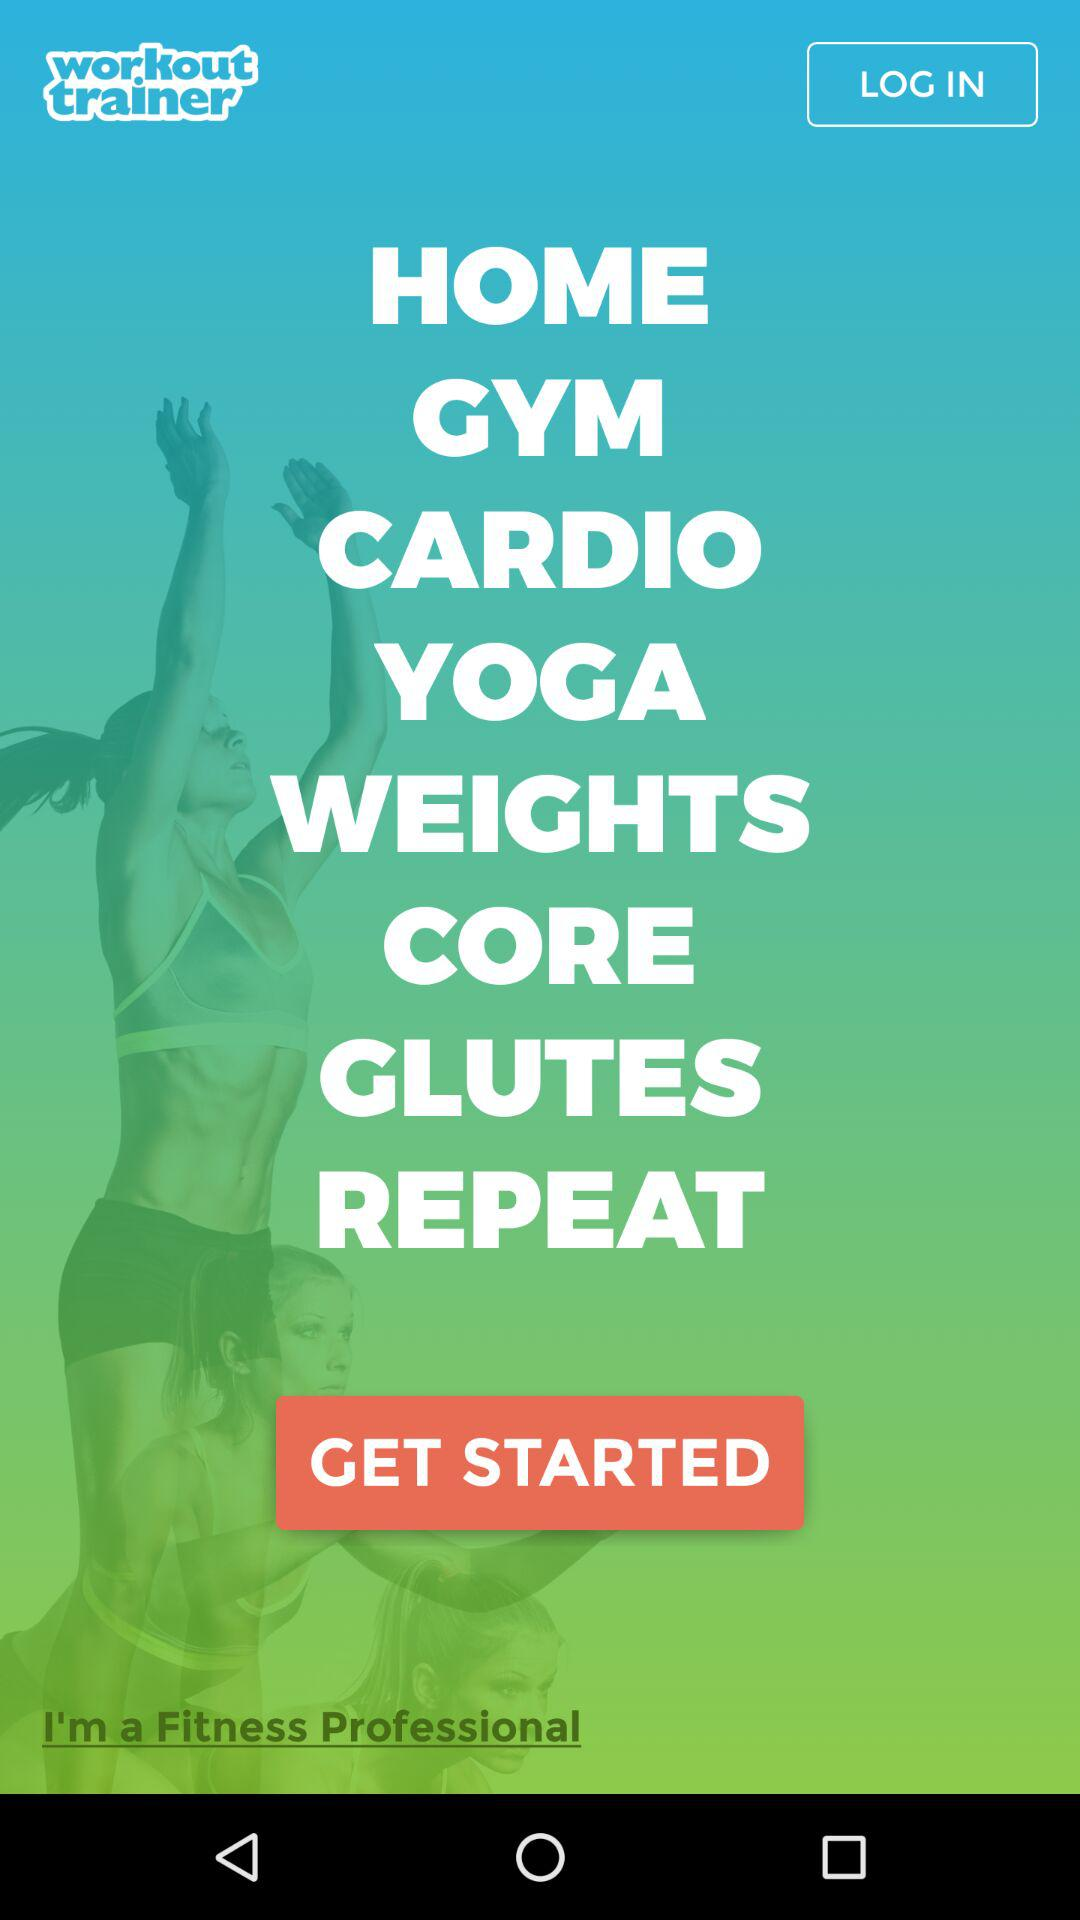What information is required for logging in?
When the provided information is insufficient, respond with <no answer>. <no answer> 